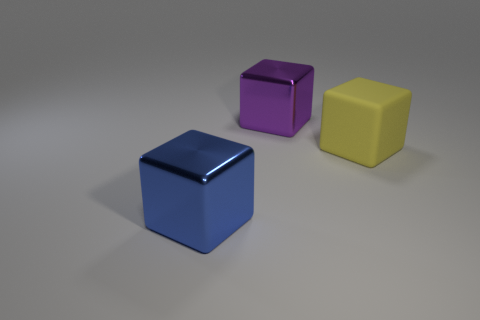Add 3 purple objects. How many objects exist? 6 Add 3 purple blocks. How many purple blocks are left? 4 Add 2 large purple cubes. How many large purple cubes exist? 3 Subtract 0 yellow cylinders. How many objects are left? 3 Subtract all matte objects. Subtract all large yellow rubber cubes. How many objects are left? 1 